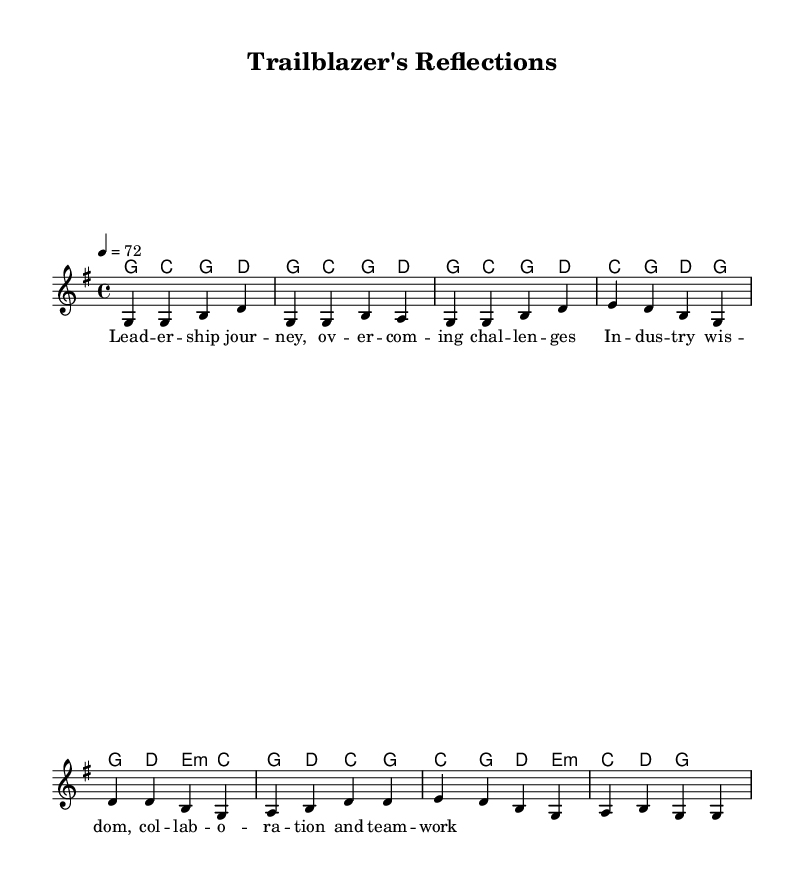What is the key signature of this music? The key signature is G major, which has one sharp (F#). This can be identified at the beginning of the staff, right after the clef sign where the sharp sign appears on the F line.
Answer: G major What is the time signature of this music? The time signature is 4/4, evident from the numbers appearing at the beginning of the sheet music indicating four beats per measure.
Answer: 4/4 What is the tempo marking of this music? The tempo marking is 4 = 72, indicating that there are 72 quarter note beats per minute. This is shown in the tempo indication found at the beginning section of the sheet music.
Answer: 72 How many measures are there in the melody part? The melody consists of eight measures, as indicated by the division of the notes into four groups in both the verse and chorus sections. Each group represents a measure.
Answer: 8 What is the name of this piece? The name of the piece is "Trailblazer's Reflections," which is mentioned in the header section of the sheet music.
Answer: Trailblazer's Reflections What themes are reflected in the lyrics of this piece? The themes reflected include leadership and collaboration, as indicated by the lyrics discussing overcoming challenges and teamwork in professional contexts.
Answer: Leadership and collaboration What chord follows the D chord in the chorus? The chord that follows the D chord in the chorus is E minor, which is shown in the chord changes presented in the harmonies section during the chorus lines.
Answer: E minor 